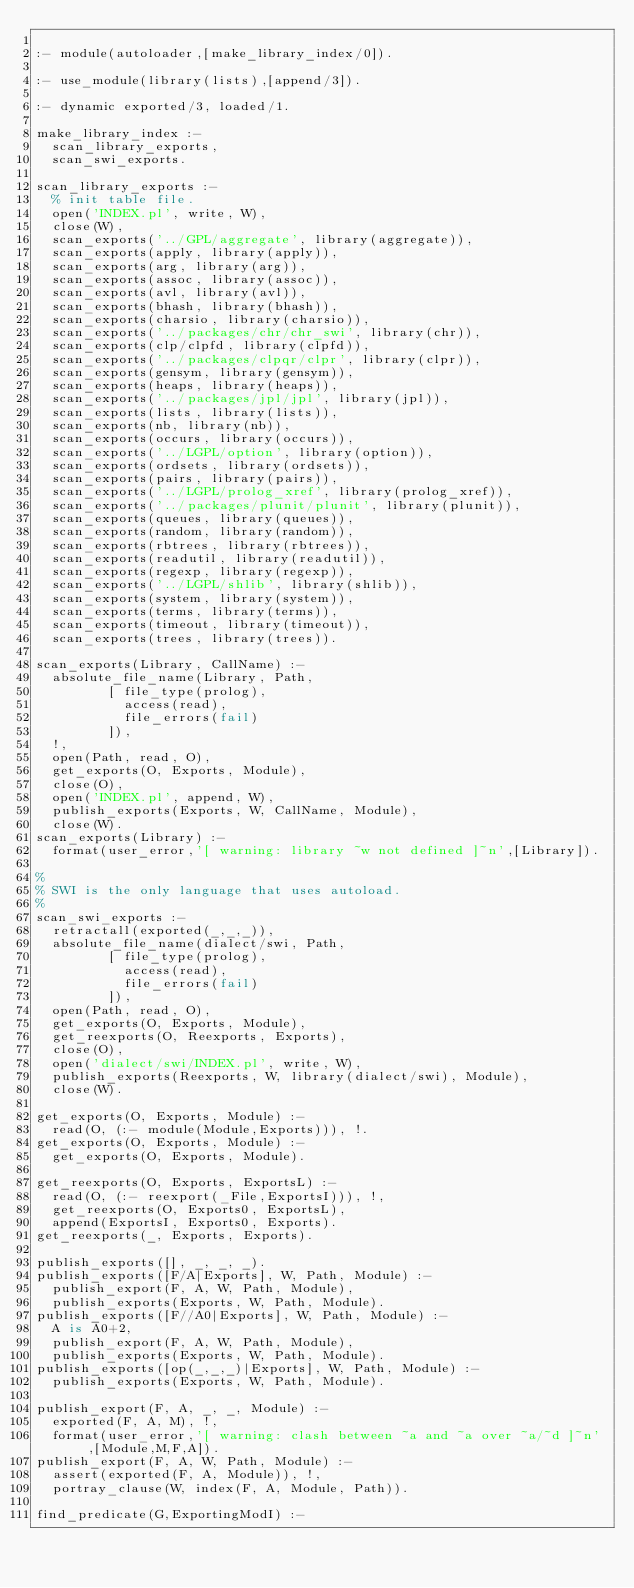Convert code to text. <code><loc_0><loc_0><loc_500><loc_500><_Prolog_>
:- module(autoloader,[make_library_index/0]).

:- use_module(library(lists),[append/3]).

:- dynamic exported/3, loaded/1.

make_library_index :-
	scan_library_exports,
	scan_swi_exports.

scan_library_exports :-
	% init table file.
	open('INDEX.pl', write, W),
	close(W),
	scan_exports('../GPL/aggregate', library(aggregate)),
	scan_exports(apply, library(apply)),
	scan_exports(arg, library(arg)),
	scan_exports(assoc, library(assoc)),
	scan_exports(avl, library(avl)),
	scan_exports(bhash, library(bhash)),
	scan_exports(charsio, library(charsio)),
	scan_exports('../packages/chr/chr_swi', library(chr)),
	scan_exports(clp/clpfd, library(clpfd)),
	scan_exports('../packages/clpqr/clpr', library(clpr)),
	scan_exports(gensym, library(gensym)),
	scan_exports(heaps, library(heaps)),
	scan_exports('../packages/jpl/jpl', library(jpl)),
	scan_exports(lists, library(lists)),
	scan_exports(nb, library(nb)),
	scan_exports(occurs, library(occurs)),
	scan_exports('../LGPL/option', library(option)),
	scan_exports(ordsets, library(ordsets)),
	scan_exports(pairs, library(pairs)),
	scan_exports('../LGPL/prolog_xref', library(prolog_xref)),
	scan_exports('../packages/plunit/plunit', library(plunit)),
	scan_exports(queues, library(queues)),
	scan_exports(random, library(random)),
	scan_exports(rbtrees, library(rbtrees)),
	scan_exports(readutil, library(readutil)),
	scan_exports(regexp, library(regexp)),
	scan_exports('../LGPL/shlib', library(shlib)),
	scan_exports(system, library(system)),
	scan_exports(terms, library(terms)),
	scan_exports(timeout, library(timeout)),
	scan_exports(trees, library(trees)).

scan_exports(Library, CallName) :-
	absolute_file_name(Library, Path,
			   [ file_type(prolog),
			     access(read),
			     file_errors(fail)
			   ]),
	!,
	open(Path, read, O),
	get_exports(O, Exports, Module),
	close(O),
	open('INDEX.pl', append, W),
	publish_exports(Exports, W, CallName, Module),
	close(W).
scan_exports(Library) :-
	format(user_error,'[ warning: library ~w not defined ]~n',[Library]).
	
%
% SWI is the only language that uses autoload.
%
scan_swi_exports :-
	retractall(exported(_,_,_)),
	absolute_file_name(dialect/swi, Path,
			   [ file_type(prolog),
			     access(read),
			     file_errors(fail)
			   ]),
	open(Path, read, O),
	get_exports(O, Exports, Module),
	get_reexports(O, Reexports, Exports),
	close(O),	
	open('dialect/swi/INDEX.pl', write, W),
	publish_exports(Reexports, W, library(dialect/swi), Module),
	close(W).

get_exports(O, Exports, Module) :-
	read(O, (:- module(Module,Exports))), !.
get_exports(O, Exports, Module) :-
	get_exports(O, Exports, Module).

get_reexports(O, Exports, ExportsL) :-
	read(O, (:- reexport(_File,ExportsI))), !,
	get_reexports(O, Exports0, ExportsL),
	append(ExportsI, Exports0, Exports).
get_reexports(_, Exports, Exports).

publish_exports([], _, _, _).
publish_exports([F/A|Exports], W, Path, Module) :-
	publish_export(F, A, W, Path, Module),
	publish_exports(Exports, W, Path, Module).
publish_exports([F//A0|Exports], W, Path, Module) :-
	A is A0+2,
	publish_export(F, A, W, Path, Module),
	publish_exports(Exports, W, Path, Module).
publish_exports([op(_,_,_)|Exports], W, Path, Module) :-
	publish_exports(Exports, W, Path, Module).

publish_export(F, A, _, _, Module) :-
	exported(F, A, M), !,
	format(user_error,'[ warning: clash between ~a and ~a over ~a/~d ]~n',[Module,M,F,A]).
publish_export(F, A, W, Path, Module) :-
	assert(exported(F, A, Module)), !,
	portray_clause(W, index(F, A, Module, Path)).

find_predicate(G,ExportingModI) :-</code> 